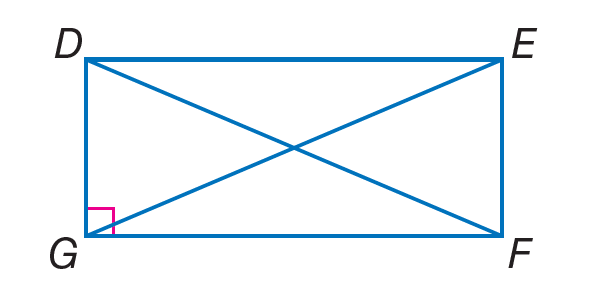Answer the mathemtical geometry problem and directly provide the correct option letter.
Question: Quadrilateral D E F G is a rectangle. If D F = 2(x + 5) - 7 and E G = 3(x - 2), find E G.
Choices: A: 6.5 B: 10 C: 21 D: 30 C 